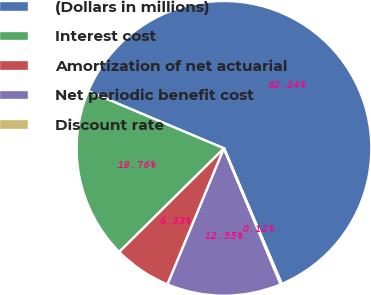<chart> <loc_0><loc_0><loc_500><loc_500><pie_chart><fcel>(Dollars in millions)<fcel>Interest cost<fcel>Amortization of net actuarial<fcel>Net periodic benefit cost<fcel>Discount rate<nl><fcel>62.24%<fcel>18.76%<fcel>6.33%<fcel>12.55%<fcel>0.12%<nl></chart> 